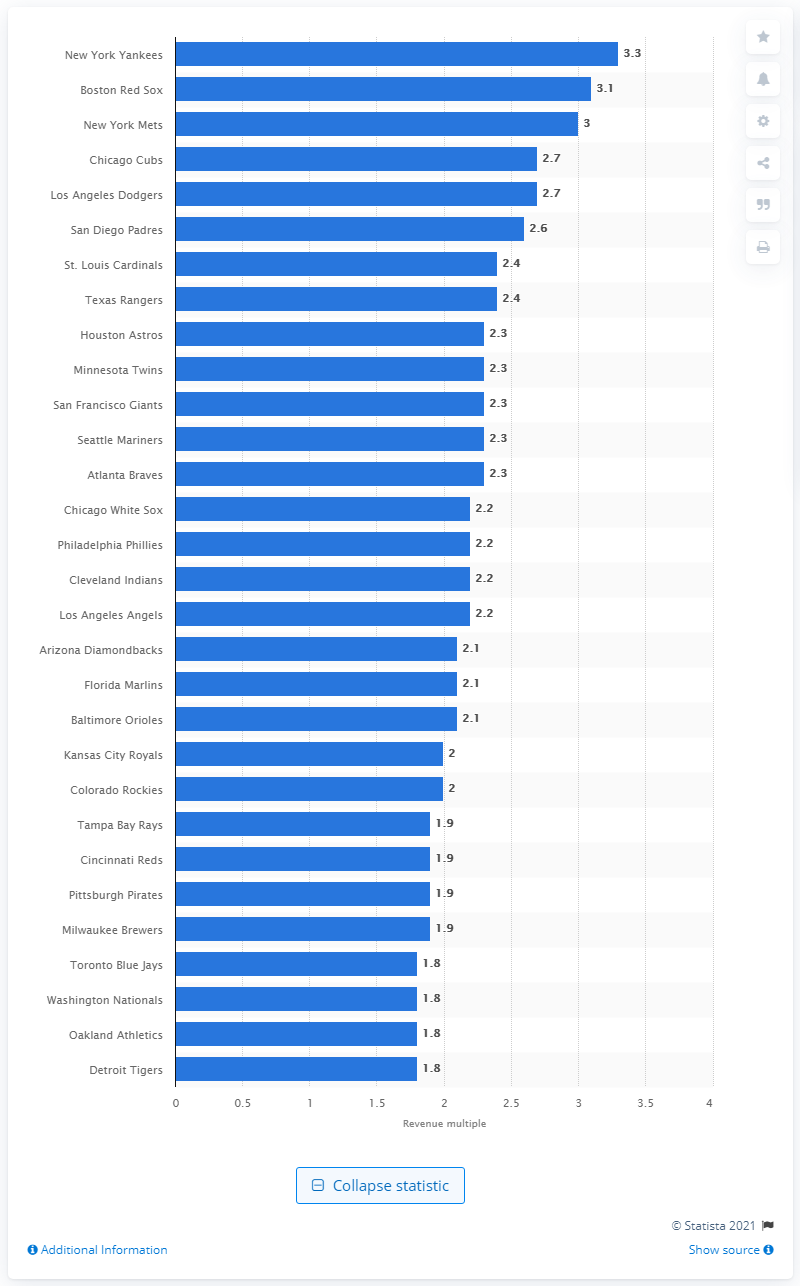Highlight a few significant elements in this photo. The revenue multiple of the Houston Astros in 2010 was 2.3. 